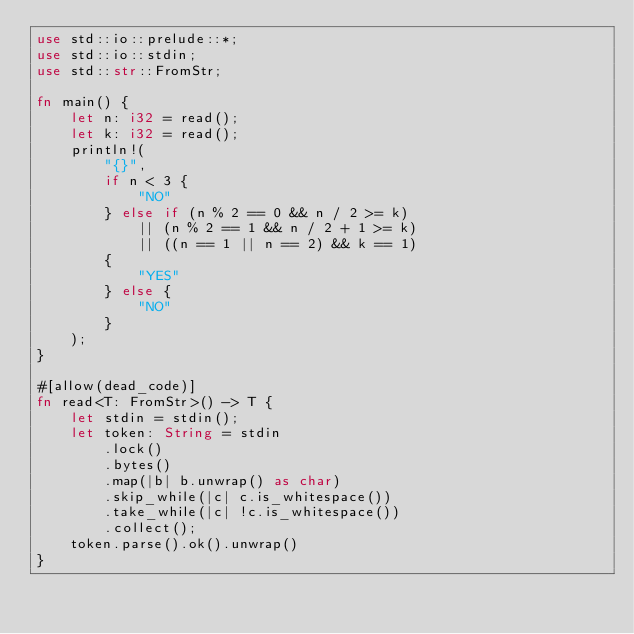Convert code to text. <code><loc_0><loc_0><loc_500><loc_500><_Rust_>use std::io::prelude::*;
use std::io::stdin;
use std::str::FromStr;

fn main() {
    let n: i32 = read();
    let k: i32 = read();
    println!(
        "{}",
        if n < 3 {
            "NO"
        } else if (n % 2 == 0 && n / 2 >= k)
            || (n % 2 == 1 && n / 2 + 1 >= k)
            || ((n == 1 || n == 2) && k == 1)
        {
            "YES"
        } else {
            "NO"
        }
    );
}

#[allow(dead_code)]
fn read<T: FromStr>() -> T {
    let stdin = stdin();
    let token: String = stdin
        .lock()
        .bytes()
        .map(|b| b.unwrap() as char)
        .skip_while(|c| c.is_whitespace())
        .take_while(|c| !c.is_whitespace())
        .collect();
    token.parse().ok().unwrap()
}
</code> 